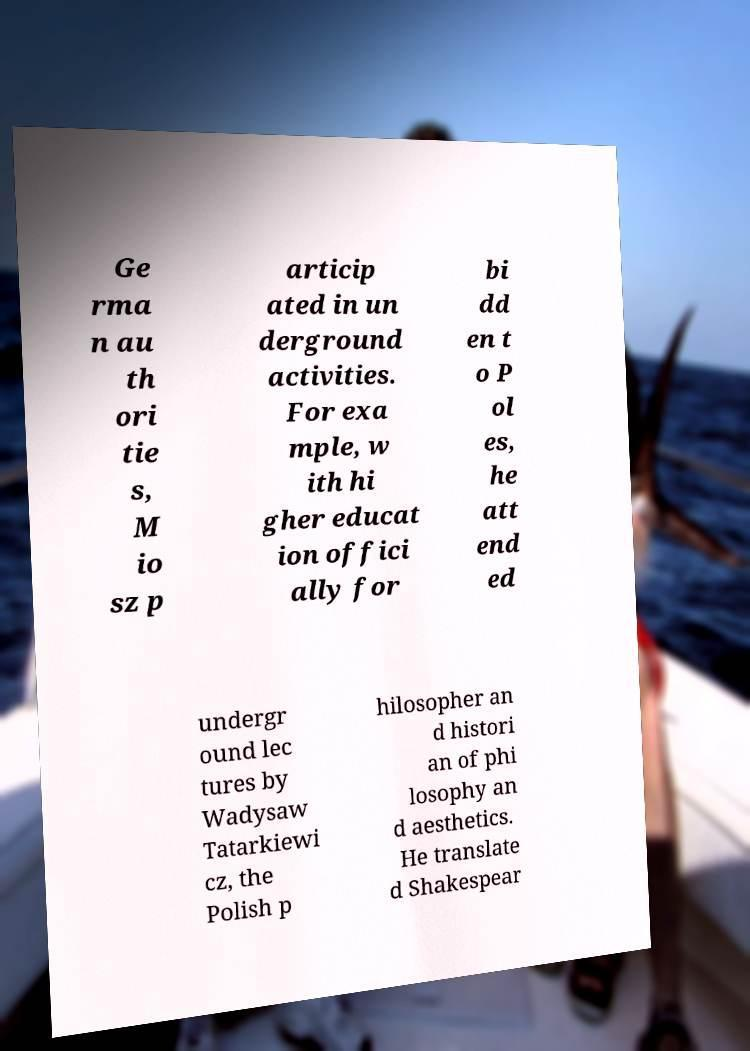There's text embedded in this image that I need extracted. Can you transcribe it verbatim? Ge rma n au th ori tie s, M io sz p articip ated in un derground activities. For exa mple, w ith hi gher educat ion offici ally for bi dd en t o P ol es, he att end ed undergr ound lec tures by Wadysaw Tatarkiewi cz, the Polish p hilosopher an d histori an of phi losophy an d aesthetics. He translate d Shakespear 